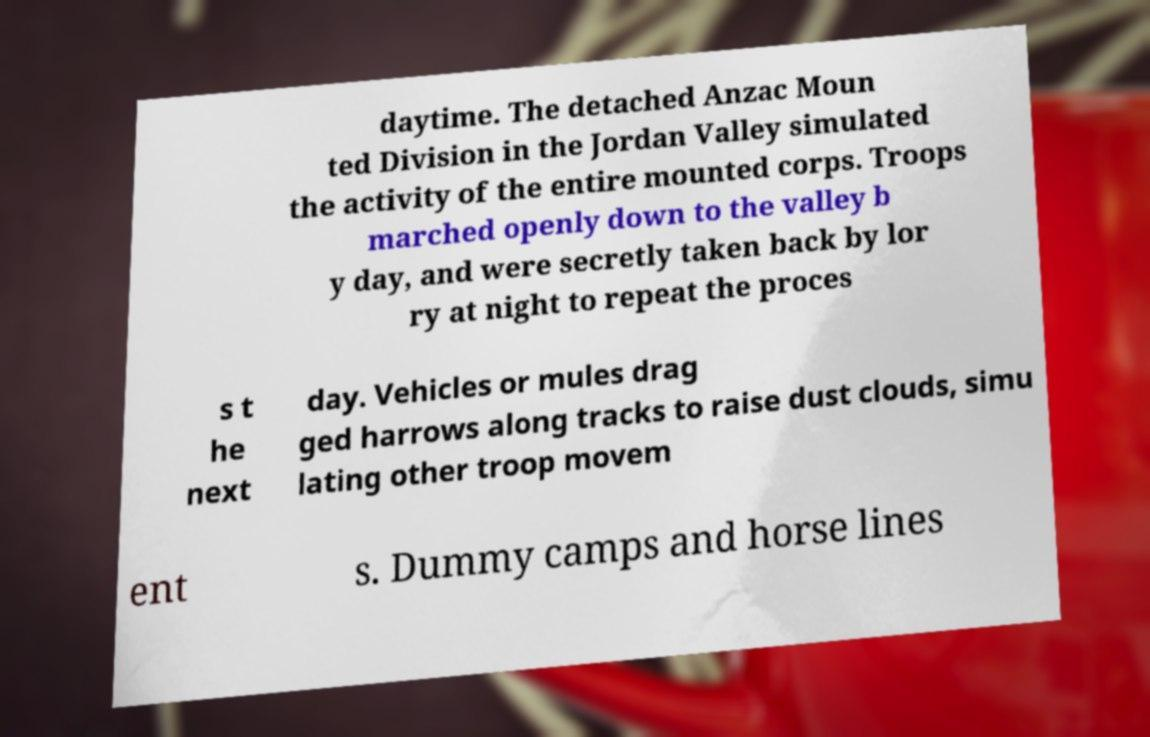Could you assist in decoding the text presented in this image and type it out clearly? daytime. The detached Anzac Moun ted Division in the Jordan Valley simulated the activity of the entire mounted corps. Troops marched openly down to the valley b y day, and were secretly taken back by lor ry at night to repeat the proces s t he next day. Vehicles or mules drag ged harrows along tracks to raise dust clouds, simu lating other troop movem ent s. Dummy camps and horse lines 